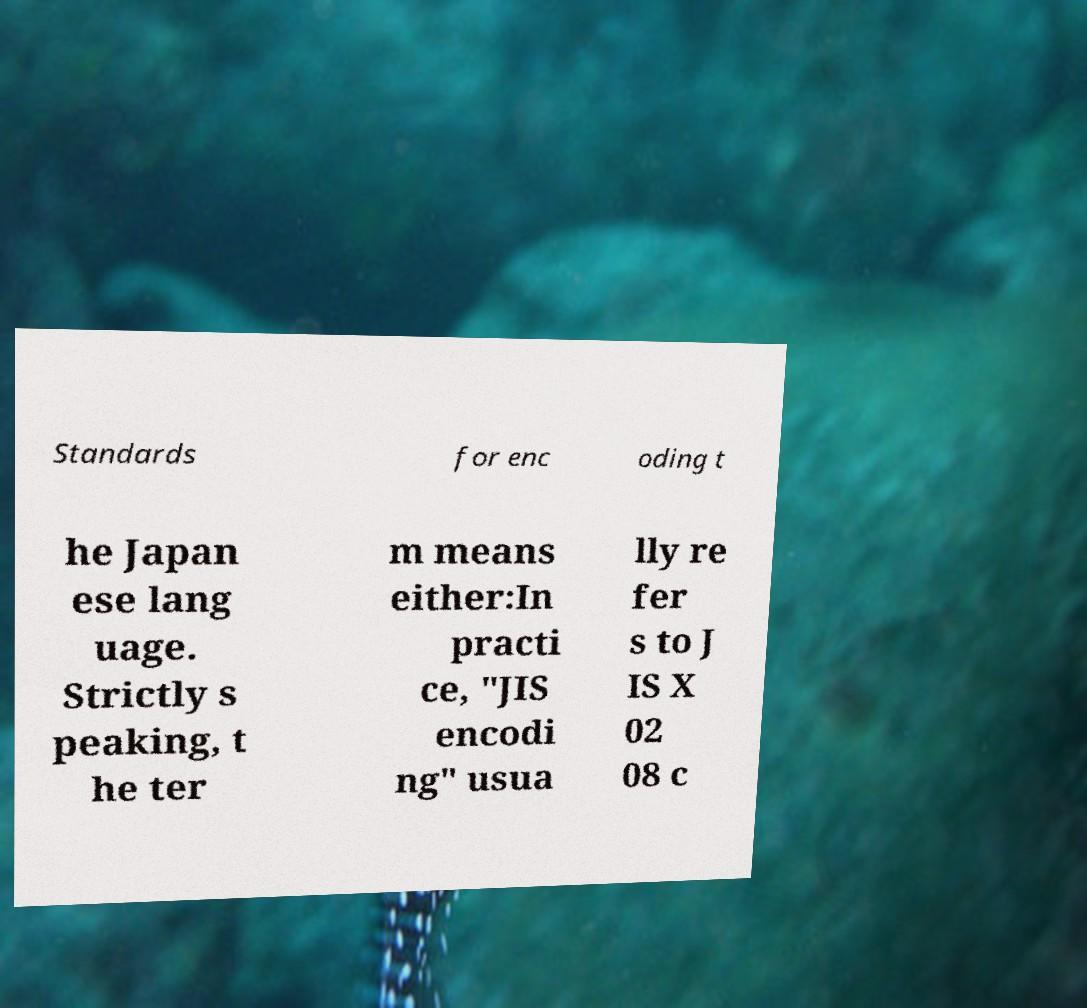For documentation purposes, I need the text within this image transcribed. Could you provide that? Standards for enc oding t he Japan ese lang uage. Strictly s peaking, t he ter m means either:In practi ce, "JIS encodi ng" usua lly re fer s to J IS X 02 08 c 